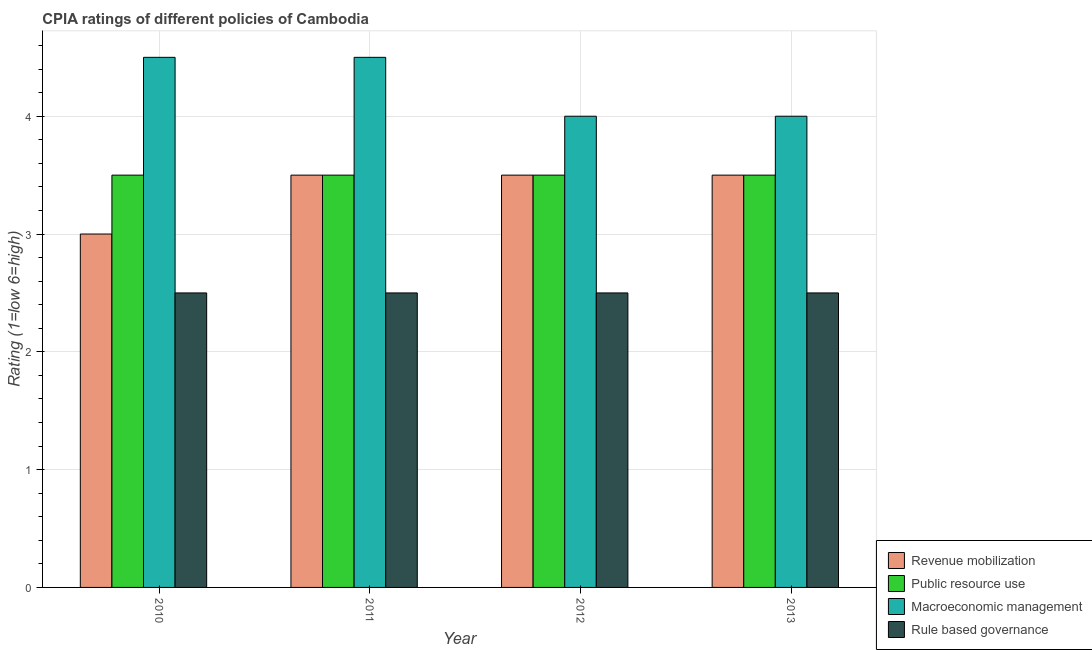In how many cases, is the number of bars for a given year not equal to the number of legend labels?
Keep it short and to the point. 0. What is the cpia rating of macroeconomic management in 2010?
Your response must be concise. 4.5. Across all years, what is the maximum cpia rating of macroeconomic management?
Your response must be concise. 4.5. In which year was the cpia rating of rule based governance maximum?
Offer a very short reply. 2010. What is the difference between the cpia rating of revenue mobilization in 2010 and that in 2013?
Your response must be concise. -0.5. What is the difference between the cpia rating of public resource use in 2012 and the cpia rating of macroeconomic management in 2011?
Give a very brief answer. 0. What is the average cpia rating of revenue mobilization per year?
Offer a very short reply. 3.38. In how many years, is the cpia rating of macroeconomic management greater than 4.4?
Your response must be concise. 2. Is the difference between the cpia rating of revenue mobilization in 2011 and 2013 greater than the difference between the cpia rating of macroeconomic management in 2011 and 2013?
Offer a very short reply. No. What is the difference between the highest and the lowest cpia rating of rule based governance?
Provide a short and direct response. 0. In how many years, is the cpia rating of revenue mobilization greater than the average cpia rating of revenue mobilization taken over all years?
Offer a very short reply. 3. What does the 3rd bar from the left in 2011 represents?
Your response must be concise. Macroeconomic management. What does the 4th bar from the right in 2012 represents?
Provide a short and direct response. Revenue mobilization. Is it the case that in every year, the sum of the cpia rating of revenue mobilization and cpia rating of public resource use is greater than the cpia rating of macroeconomic management?
Give a very brief answer. Yes. What is the difference between two consecutive major ticks on the Y-axis?
Offer a very short reply. 1. Does the graph contain any zero values?
Keep it short and to the point. No. Where does the legend appear in the graph?
Make the answer very short. Bottom right. How many legend labels are there?
Your answer should be very brief. 4. How are the legend labels stacked?
Provide a short and direct response. Vertical. What is the title of the graph?
Ensure brevity in your answer.  CPIA ratings of different policies of Cambodia. What is the label or title of the X-axis?
Ensure brevity in your answer.  Year. What is the label or title of the Y-axis?
Give a very brief answer. Rating (1=low 6=high). What is the Rating (1=low 6=high) of Revenue mobilization in 2010?
Offer a terse response. 3. What is the Rating (1=low 6=high) in Public resource use in 2010?
Provide a short and direct response. 3.5. What is the Rating (1=low 6=high) of Macroeconomic management in 2010?
Offer a terse response. 4.5. What is the Rating (1=low 6=high) of Revenue mobilization in 2011?
Ensure brevity in your answer.  3.5. What is the Rating (1=low 6=high) in Macroeconomic management in 2011?
Make the answer very short. 4.5. What is the Rating (1=low 6=high) in Public resource use in 2012?
Provide a succinct answer. 3.5. What is the Rating (1=low 6=high) of Macroeconomic management in 2013?
Your response must be concise. 4. What is the Rating (1=low 6=high) of Rule based governance in 2013?
Provide a short and direct response. 2.5. Across all years, what is the minimum Rating (1=low 6=high) in Macroeconomic management?
Offer a terse response. 4. What is the total Rating (1=low 6=high) of Macroeconomic management in the graph?
Make the answer very short. 17. What is the total Rating (1=low 6=high) in Rule based governance in the graph?
Your answer should be compact. 10. What is the difference between the Rating (1=low 6=high) of Rule based governance in 2010 and that in 2011?
Keep it short and to the point. 0. What is the difference between the Rating (1=low 6=high) of Revenue mobilization in 2010 and that in 2012?
Give a very brief answer. -0.5. What is the difference between the Rating (1=low 6=high) of Public resource use in 2010 and that in 2012?
Your response must be concise. 0. What is the difference between the Rating (1=low 6=high) in Rule based governance in 2010 and that in 2012?
Your answer should be very brief. 0. What is the difference between the Rating (1=low 6=high) of Public resource use in 2010 and that in 2013?
Offer a terse response. 0. What is the difference between the Rating (1=low 6=high) in Macroeconomic management in 2010 and that in 2013?
Make the answer very short. 0.5. What is the difference between the Rating (1=low 6=high) of Rule based governance in 2010 and that in 2013?
Provide a short and direct response. 0. What is the difference between the Rating (1=low 6=high) in Revenue mobilization in 2011 and that in 2012?
Provide a succinct answer. 0. What is the difference between the Rating (1=low 6=high) in Macroeconomic management in 2011 and that in 2012?
Your response must be concise. 0.5. What is the difference between the Rating (1=low 6=high) of Rule based governance in 2011 and that in 2012?
Offer a terse response. 0. What is the difference between the Rating (1=low 6=high) in Macroeconomic management in 2011 and that in 2013?
Keep it short and to the point. 0.5. What is the difference between the Rating (1=low 6=high) in Macroeconomic management in 2012 and that in 2013?
Make the answer very short. 0. What is the difference between the Rating (1=low 6=high) of Rule based governance in 2012 and that in 2013?
Ensure brevity in your answer.  0. What is the difference between the Rating (1=low 6=high) of Revenue mobilization in 2010 and the Rating (1=low 6=high) of Public resource use in 2011?
Offer a very short reply. -0.5. What is the difference between the Rating (1=low 6=high) in Revenue mobilization in 2010 and the Rating (1=low 6=high) in Macroeconomic management in 2011?
Your response must be concise. -1.5. What is the difference between the Rating (1=low 6=high) in Revenue mobilization in 2010 and the Rating (1=low 6=high) in Rule based governance in 2011?
Provide a short and direct response. 0.5. What is the difference between the Rating (1=low 6=high) of Macroeconomic management in 2010 and the Rating (1=low 6=high) of Rule based governance in 2011?
Your response must be concise. 2. What is the difference between the Rating (1=low 6=high) of Macroeconomic management in 2010 and the Rating (1=low 6=high) of Rule based governance in 2012?
Provide a short and direct response. 2. What is the difference between the Rating (1=low 6=high) in Revenue mobilization in 2010 and the Rating (1=low 6=high) in Rule based governance in 2013?
Keep it short and to the point. 0.5. What is the difference between the Rating (1=low 6=high) in Macroeconomic management in 2010 and the Rating (1=low 6=high) in Rule based governance in 2013?
Your answer should be very brief. 2. What is the difference between the Rating (1=low 6=high) of Revenue mobilization in 2011 and the Rating (1=low 6=high) of Public resource use in 2012?
Provide a short and direct response. 0. What is the difference between the Rating (1=low 6=high) in Revenue mobilization in 2011 and the Rating (1=low 6=high) in Macroeconomic management in 2012?
Make the answer very short. -0.5. What is the difference between the Rating (1=low 6=high) of Revenue mobilization in 2011 and the Rating (1=low 6=high) of Rule based governance in 2012?
Your answer should be compact. 1. What is the difference between the Rating (1=low 6=high) of Public resource use in 2011 and the Rating (1=low 6=high) of Rule based governance in 2012?
Your answer should be very brief. 1. What is the difference between the Rating (1=low 6=high) of Macroeconomic management in 2011 and the Rating (1=low 6=high) of Rule based governance in 2012?
Offer a very short reply. 2. What is the difference between the Rating (1=low 6=high) in Revenue mobilization in 2011 and the Rating (1=low 6=high) in Public resource use in 2013?
Give a very brief answer. 0. What is the difference between the Rating (1=low 6=high) of Public resource use in 2011 and the Rating (1=low 6=high) of Macroeconomic management in 2013?
Make the answer very short. -0.5. What is the difference between the Rating (1=low 6=high) in Revenue mobilization in 2012 and the Rating (1=low 6=high) in Public resource use in 2013?
Keep it short and to the point. 0. What is the difference between the Rating (1=low 6=high) of Revenue mobilization in 2012 and the Rating (1=low 6=high) of Rule based governance in 2013?
Ensure brevity in your answer.  1. What is the difference between the Rating (1=low 6=high) of Public resource use in 2012 and the Rating (1=low 6=high) of Macroeconomic management in 2013?
Make the answer very short. -0.5. What is the difference between the Rating (1=low 6=high) of Public resource use in 2012 and the Rating (1=low 6=high) of Rule based governance in 2013?
Ensure brevity in your answer.  1. What is the average Rating (1=low 6=high) of Revenue mobilization per year?
Your response must be concise. 3.38. What is the average Rating (1=low 6=high) in Public resource use per year?
Give a very brief answer. 3.5. What is the average Rating (1=low 6=high) in Macroeconomic management per year?
Your response must be concise. 4.25. What is the average Rating (1=low 6=high) of Rule based governance per year?
Ensure brevity in your answer.  2.5. In the year 2010, what is the difference between the Rating (1=low 6=high) in Revenue mobilization and Rating (1=low 6=high) in Public resource use?
Your answer should be compact. -0.5. In the year 2010, what is the difference between the Rating (1=low 6=high) of Revenue mobilization and Rating (1=low 6=high) of Macroeconomic management?
Your answer should be very brief. -1.5. In the year 2010, what is the difference between the Rating (1=low 6=high) of Revenue mobilization and Rating (1=low 6=high) of Rule based governance?
Provide a short and direct response. 0.5. In the year 2010, what is the difference between the Rating (1=low 6=high) of Public resource use and Rating (1=low 6=high) of Rule based governance?
Ensure brevity in your answer.  1. In the year 2010, what is the difference between the Rating (1=low 6=high) of Macroeconomic management and Rating (1=low 6=high) of Rule based governance?
Ensure brevity in your answer.  2. In the year 2011, what is the difference between the Rating (1=low 6=high) of Revenue mobilization and Rating (1=low 6=high) of Public resource use?
Give a very brief answer. 0. In the year 2011, what is the difference between the Rating (1=low 6=high) of Revenue mobilization and Rating (1=low 6=high) of Macroeconomic management?
Your answer should be compact. -1. In the year 2011, what is the difference between the Rating (1=low 6=high) of Public resource use and Rating (1=low 6=high) of Macroeconomic management?
Your answer should be compact. -1. In the year 2011, what is the difference between the Rating (1=low 6=high) in Public resource use and Rating (1=low 6=high) in Rule based governance?
Offer a very short reply. 1. In the year 2011, what is the difference between the Rating (1=low 6=high) in Macroeconomic management and Rating (1=low 6=high) in Rule based governance?
Your answer should be very brief. 2. In the year 2012, what is the difference between the Rating (1=low 6=high) in Revenue mobilization and Rating (1=low 6=high) in Public resource use?
Keep it short and to the point. 0. In the year 2012, what is the difference between the Rating (1=low 6=high) of Revenue mobilization and Rating (1=low 6=high) of Rule based governance?
Your response must be concise. 1. In the year 2012, what is the difference between the Rating (1=low 6=high) of Public resource use and Rating (1=low 6=high) of Macroeconomic management?
Provide a succinct answer. -0.5. In the year 2012, what is the difference between the Rating (1=low 6=high) of Public resource use and Rating (1=low 6=high) of Rule based governance?
Offer a terse response. 1. In the year 2012, what is the difference between the Rating (1=low 6=high) in Macroeconomic management and Rating (1=low 6=high) in Rule based governance?
Ensure brevity in your answer.  1.5. In the year 2013, what is the difference between the Rating (1=low 6=high) in Revenue mobilization and Rating (1=low 6=high) in Public resource use?
Offer a very short reply. 0. In the year 2013, what is the difference between the Rating (1=low 6=high) of Revenue mobilization and Rating (1=low 6=high) of Macroeconomic management?
Make the answer very short. -0.5. In the year 2013, what is the difference between the Rating (1=low 6=high) of Revenue mobilization and Rating (1=low 6=high) of Rule based governance?
Ensure brevity in your answer.  1. What is the ratio of the Rating (1=low 6=high) in Macroeconomic management in 2010 to that in 2011?
Your answer should be compact. 1. What is the ratio of the Rating (1=low 6=high) in Macroeconomic management in 2010 to that in 2012?
Offer a terse response. 1.12. What is the ratio of the Rating (1=low 6=high) of Rule based governance in 2010 to that in 2012?
Ensure brevity in your answer.  1. What is the ratio of the Rating (1=low 6=high) of Rule based governance in 2010 to that in 2013?
Your answer should be compact. 1. What is the ratio of the Rating (1=low 6=high) of Rule based governance in 2011 to that in 2012?
Your answer should be compact. 1. What is the ratio of the Rating (1=low 6=high) in Macroeconomic management in 2011 to that in 2013?
Make the answer very short. 1.12. What is the ratio of the Rating (1=low 6=high) in Public resource use in 2012 to that in 2013?
Offer a very short reply. 1. What is the difference between the highest and the second highest Rating (1=low 6=high) in Macroeconomic management?
Your answer should be very brief. 0. What is the difference between the highest and the lowest Rating (1=low 6=high) in Macroeconomic management?
Your response must be concise. 0.5. 